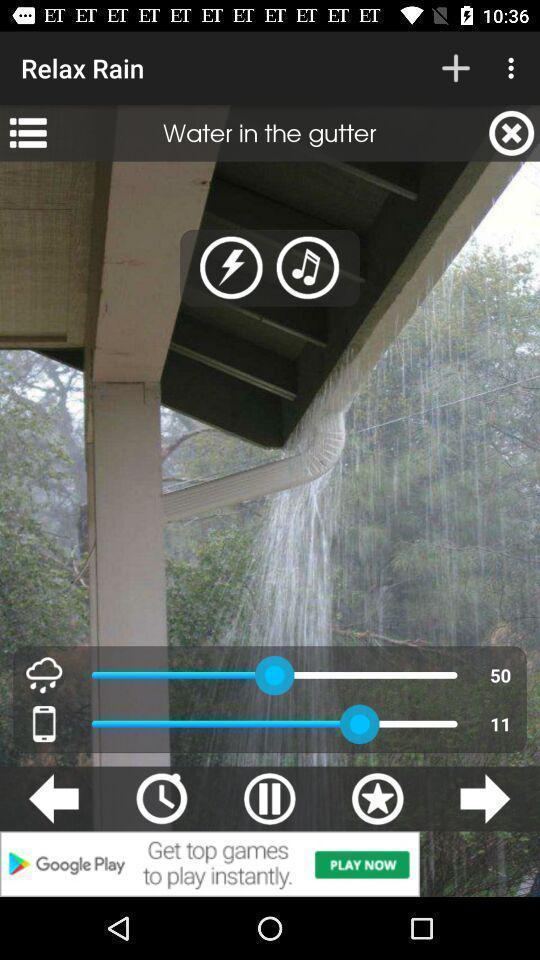Give me a summary of this screen capture. Page of a music player app. 